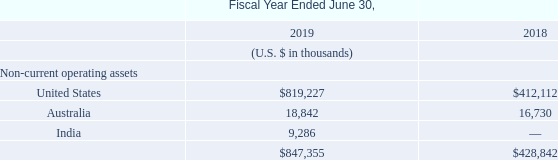20. Geographic Information
The Group’s non-current operating assets by geographic regions are as follows:
Non-current operating assets for this purpose consist of property and equipment, goodwill, intangible assets and other non-current assets.
What does non-current operating assets consists of? Property and equipment, goodwill, intangible assets and other non-current assets. What is the total non-current operating assets for fiscal year ended June 30, 2018 and 2019 respectively?
Answer scale should be: thousand. $428,842, $847,355. What is the value of non-current operating assets in India in fiscal year ended June 30, 2019?
Answer scale should be: thousand. 9,286. What is the average total non-current operating assets for fiscal years ended June 30, 2018 and 2019?
Answer scale should be: thousand. (847,355+428,842)/2
Answer: 638098.5. In fiscal year ended June 30, 2019, how many geographic regions have non-current operating assets of more than $10,000 thousand? United States ## Australia
Answer: 2. In fiscal year ended June 30, 2018, what is the percentage constitution of the non-current operating assets in the United States among the total non-current operating assets owned by the Group?
Answer scale should be: percent. 412,112/428,842
Answer: 96.1. 